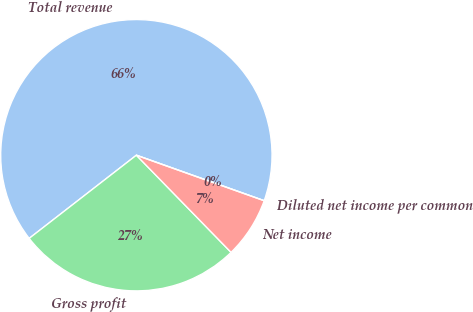Convert chart to OTSL. <chart><loc_0><loc_0><loc_500><loc_500><pie_chart><fcel>Total revenue<fcel>Gross profit<fcel>Net income<fcel>Diluted net income per common<nl><fcel>65.94%<fcel>26.79%<fcel>7.26%<fcel>0.0%<nl></chart> 